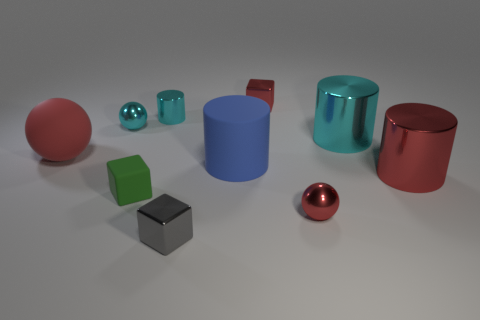There is a rubber thing that is left of the small cyan ball; is its color the same as the small shiny cube in front of the red block? no 